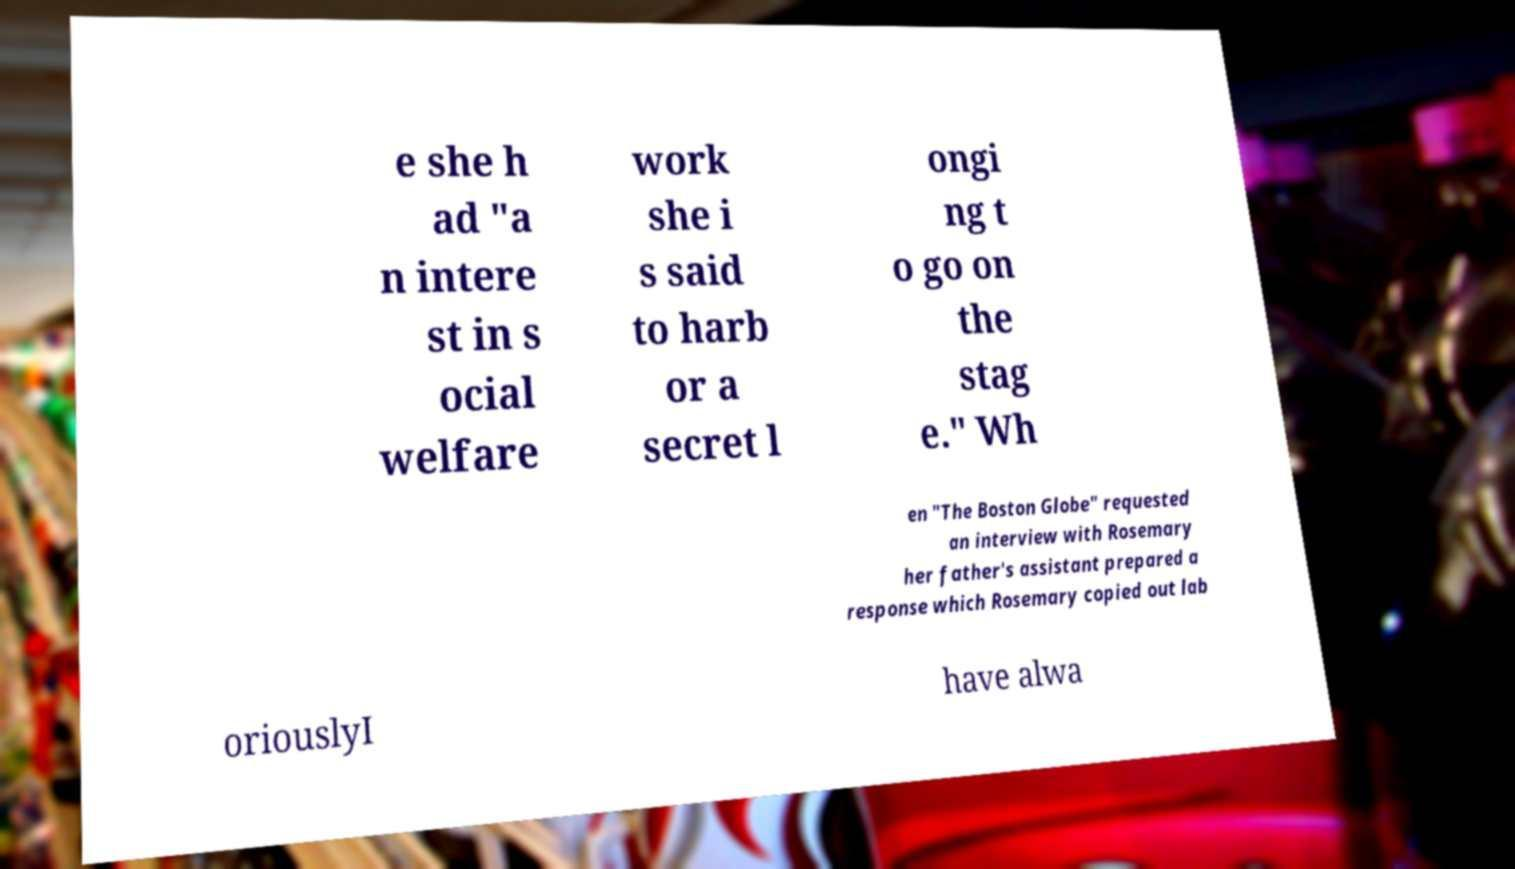Could you assist in decoding the text presented in this image and type it out clearly? e she h ad "a n intere st in s ocial welfare work she i s said to harb or a secret l ongi ng t o go on the stag e." Wh en "The Boston Globe" requested an interview with Rosemary her father's assistant prepared a response which Rosemary copied out lab oriouslyI have alwa 